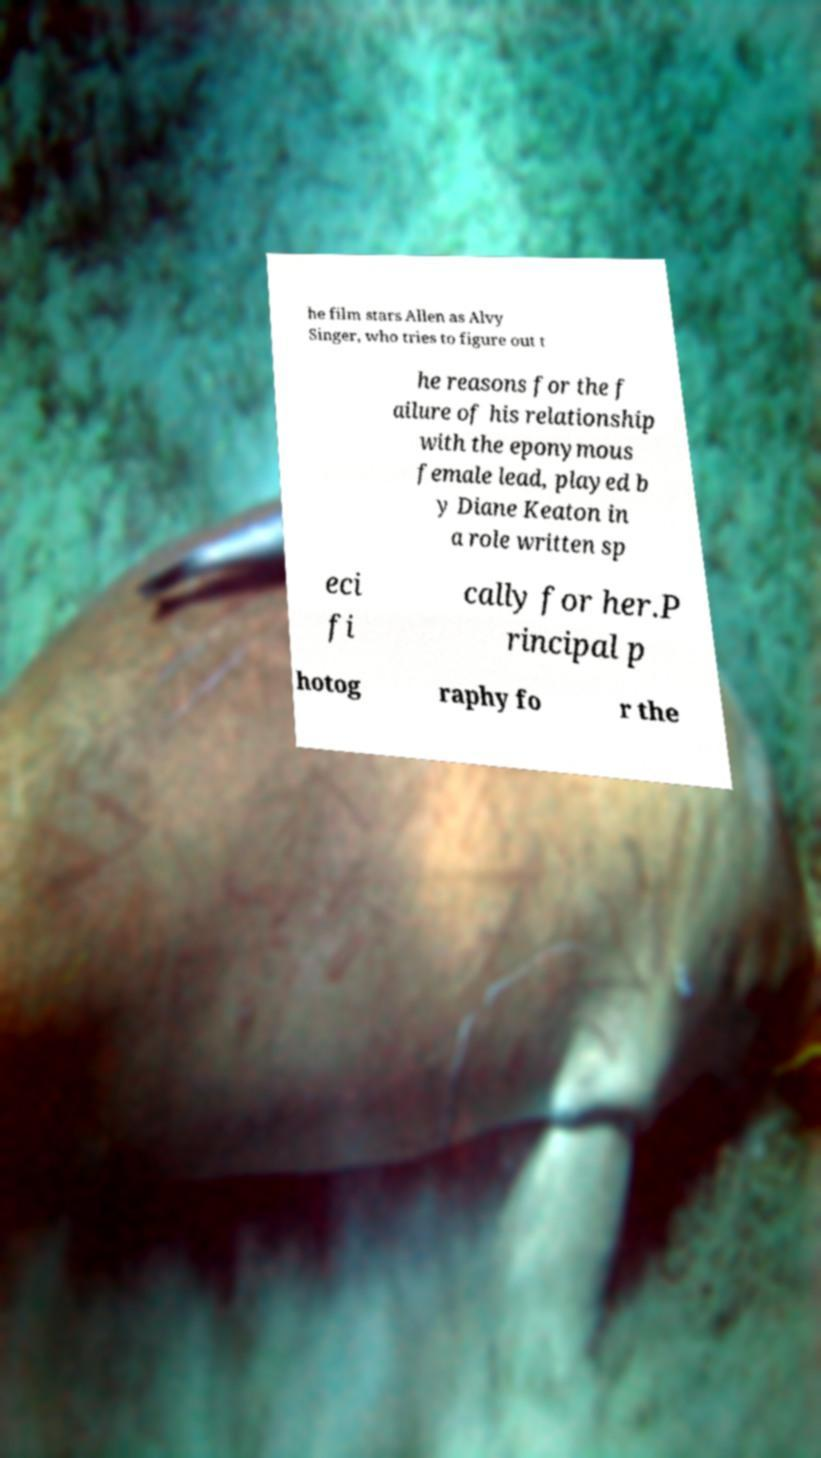There's text embedded in this image that I need extracted. Can you transcribe it verbatim? he film stars Allen as Alvy Singer, who tries to figure out t he reasons for the f ailure of his relationship with the eponymous female lead, played b y Diane Keaton in a role written sp eci fi cally for her.P rincipal p hotog raphy fo r the 